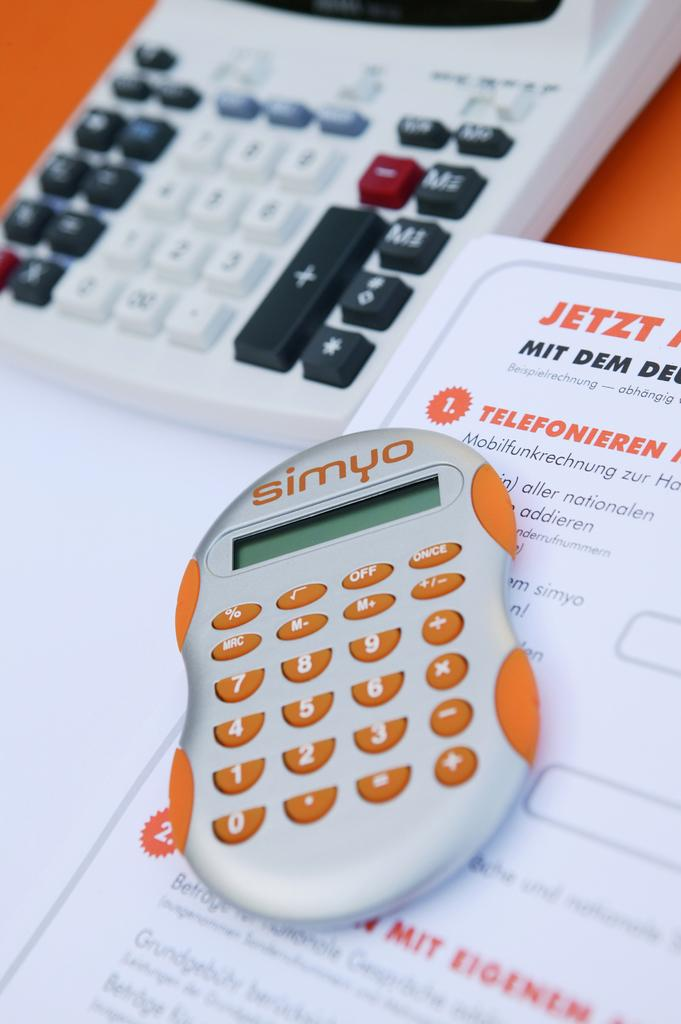<image>
Give a short and clear explanation of the subsequent image. A Simyo calculator with orange keys rests on top of a form. 